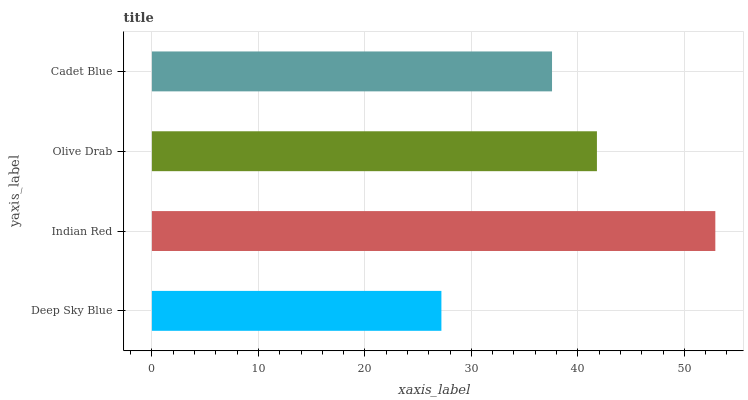Is Deep Sky Blue the minimum?
Answer yes or no. Yes. Is Indian Red the maximum?
Answer yes or no. Yes. Is Olive Drab the minimum?
Answer yes or no. No. Is Olive Drab the maximum?
Answer yes or no. No. Is Indian Red greater than Olive Drab?
Answer yes or no. Yes. Is Olive Drab less than Indian Red?
Answer yes or no. Yes. Is Olive Drab greater than Indian Red?
Answer yes or no. No. Is Indian Red less than Olive Drab?
Answer yes or no. No. Is Olive Drab the high median?
Answer yes or no. Yes. Is Cadet Blue the low median?
Answer yes or no. Yes. Is Indian Red the high median?
Answer yes or no. No. Is Olive Drab the low median?
Answer yes or no. No. 